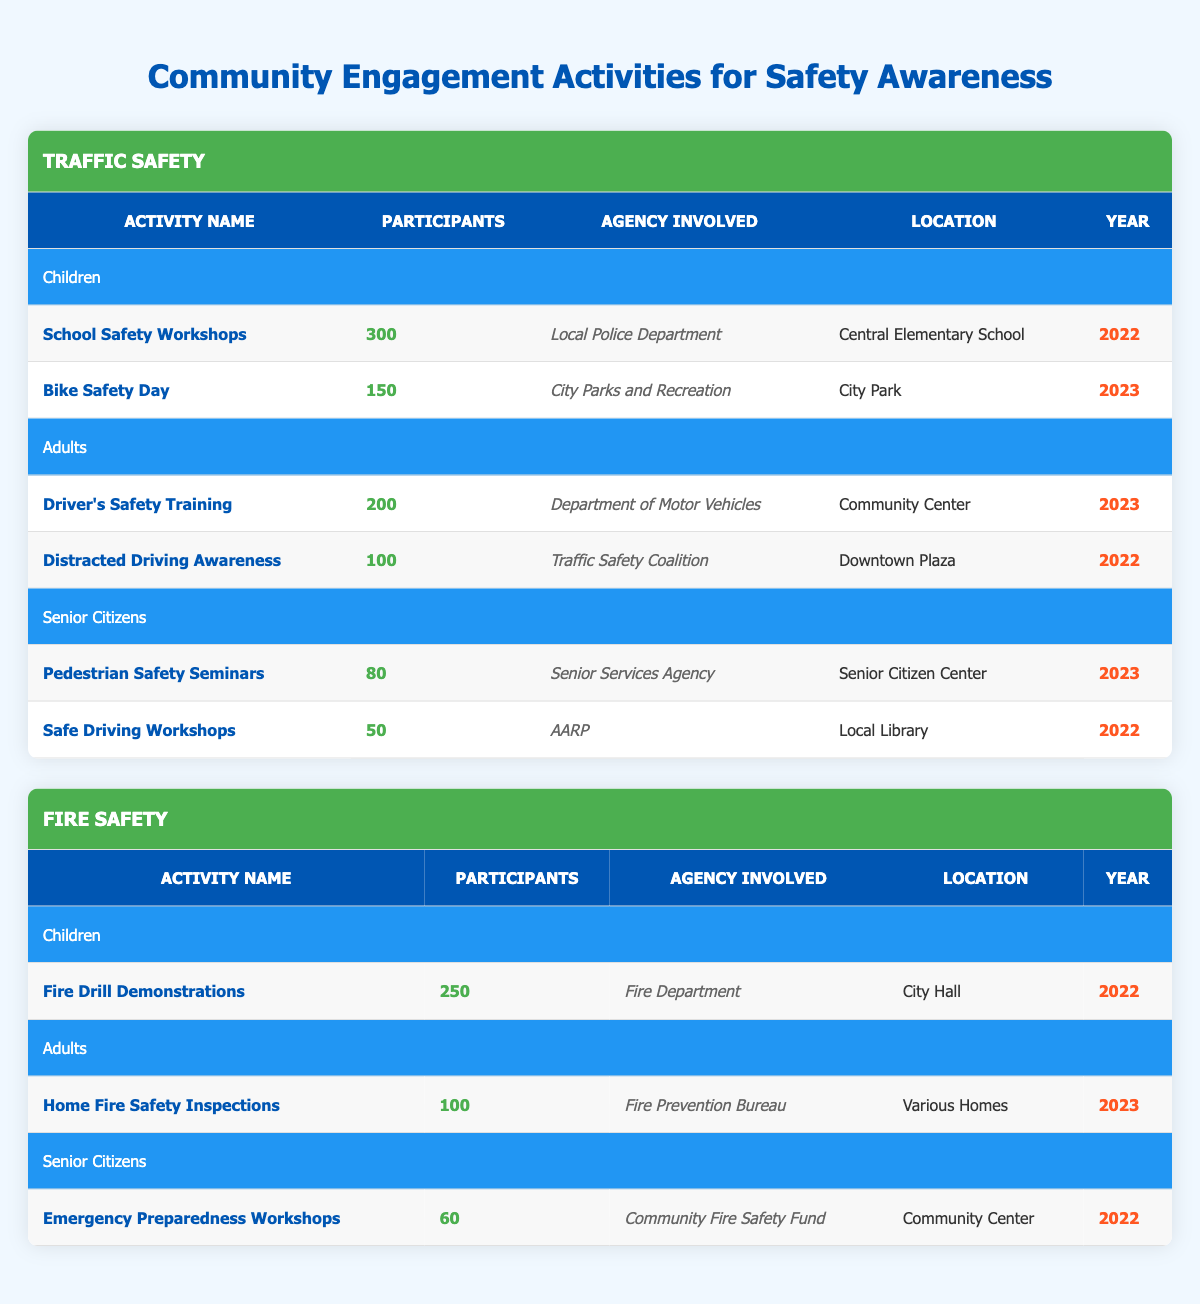What is the total number of participants in the Traffic Safety activities for Children? The table shows two activities for Children under Traffic Safety: School Safety Workshops with 300 participants and Bike Safety Day with 150 participants. Adding these, 300 + 150 equals 450 total participants.
Answer: 450 Which agency was involved in the Home Fire Safety Inspections? The table displays the agency involved in the Home Fire Safety Inspections under the Adults demographic in the Fire Safety section, which is the Fire Prevention Bureau.
Answer: Fire Prevention Bureau Did Senior Citizens participate in Fire Drill Demonstrations? The table indicates that Fire Drill Demonstrations were held for Children, and there are no records of this activity under the Senior Citizens demographic. Therefore, the answer is no.
Answer: No What year did the Pedestrian Safety Seminars take place? From the table, it is stated that the Pedestrian Safety Seminars for Senior Citizens occurred in the year 2023.
Answer: 2023 How many more participants were there in the School Safety Workshops compared to the Safe Driving Workshops? The School Safety Workshops had 300 participants and the Safe Driving Workshops had 50 participants. The difference is 300 - 50, which equals 250 more participants in the School Safety Workshops.
Answer: 250 What are the total participants in the Fire Safety activities for Adults? The Fire Safety section shows that only one activity for Adults is listed, which is Home Fire Safety Inspections with 100 participants. Therefore, the total for Adults in Fire Safety activities is 100.
Answer: 100 Is the total number of participants in Fire Safety activities greater than that in Traffic Safety activities for Seniors? The Fire Safety table shows 60 participants under Emergency Preparedness Workshops for Seniors. In Traffic Safety, the total for Senior Citizens is 80 (Pedestrian Safety Seminars). Since 60 < 80, it is clear the total participants for Fire Safety activities for Seniors is not greater.
Answer: No Which demographic had the highest number of participants in the Traffic Safety campaign? Looking at the Traffic Safety section, Children had a total of 450 participants, Adults had 300 participants, and Senior Citizens had 130 participants. Thus, Children had the highest number of participants in the Traffic Safety campaign.
Answer: Children 